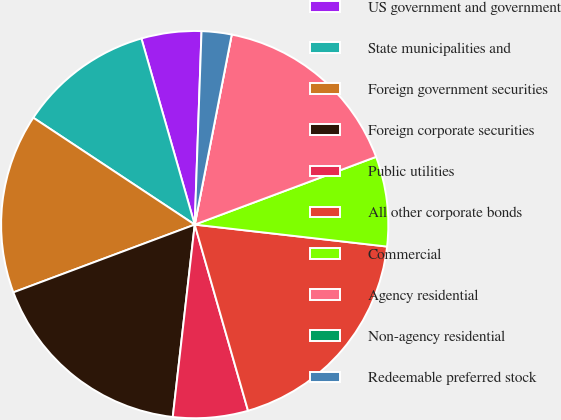Convert chart to OTSL. <chart><loc_0><loc_0><loc_500><loc_500><pie_chart><fcel>US government and government<fcel>State municipalities and<fcel>Foreign government securities<fcel>Foreign corporate securities<fcel>Public utilities<fcel>All other corporate bonds<fcel>Commercial<fcel>Agency residential<fcel>Non-agency residential<fcel>Redeemable preferred stock<nl><fcel>5.0%<fcel>11.25%<fcel>15.0%<fcel>17.5%<fcel>6.25%<fcel>18.75%<fcel>7.5%<fcel>16.25%<fcel>0.0%<fcel>2.5%<nl></chart> 